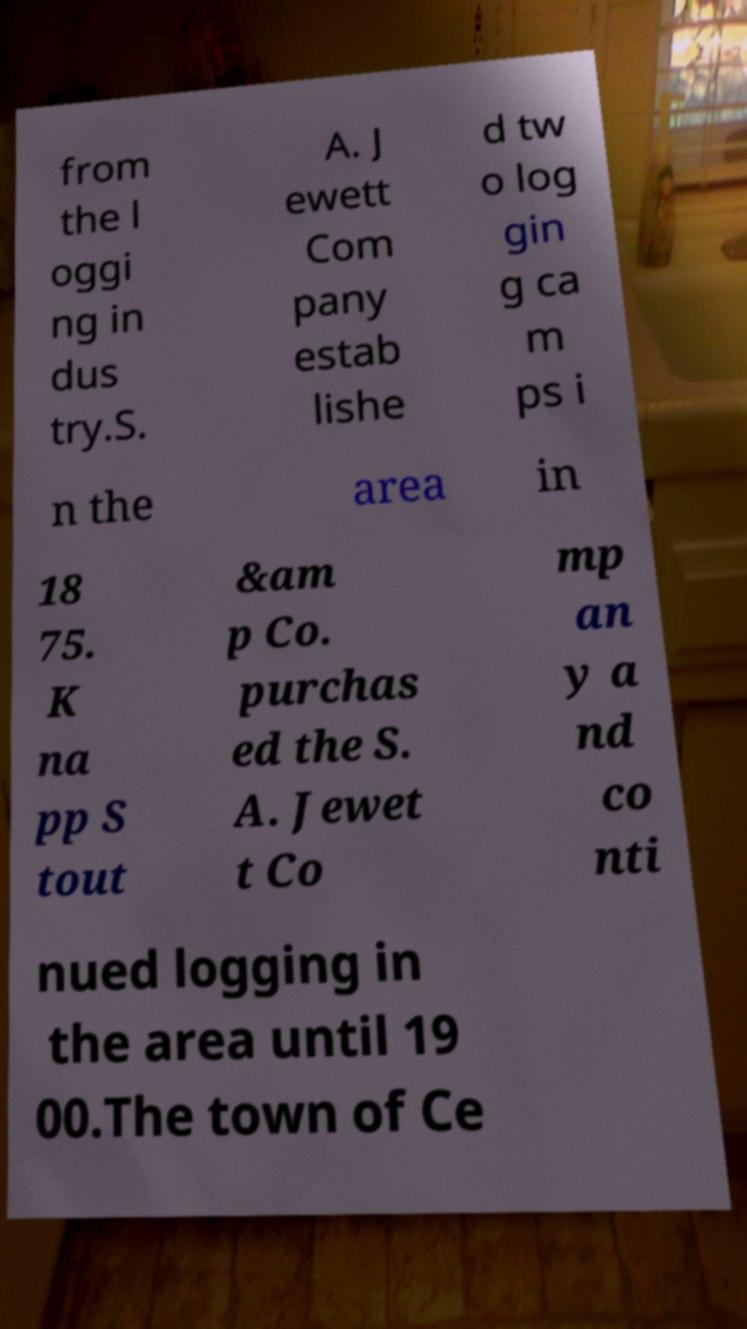Can you accurately transcribe the text from the provided image for me? from the l oggi ng in dus try.S. A. J ewett Com pany estab lishe d tw o log gin g ca m ps i n the area in 18 75. K na pp S tout &am p Co. purchas ed the S. A. Jewet t Co mp an y a nd co nti nued logging in the area until 19 00.The town of Ce 